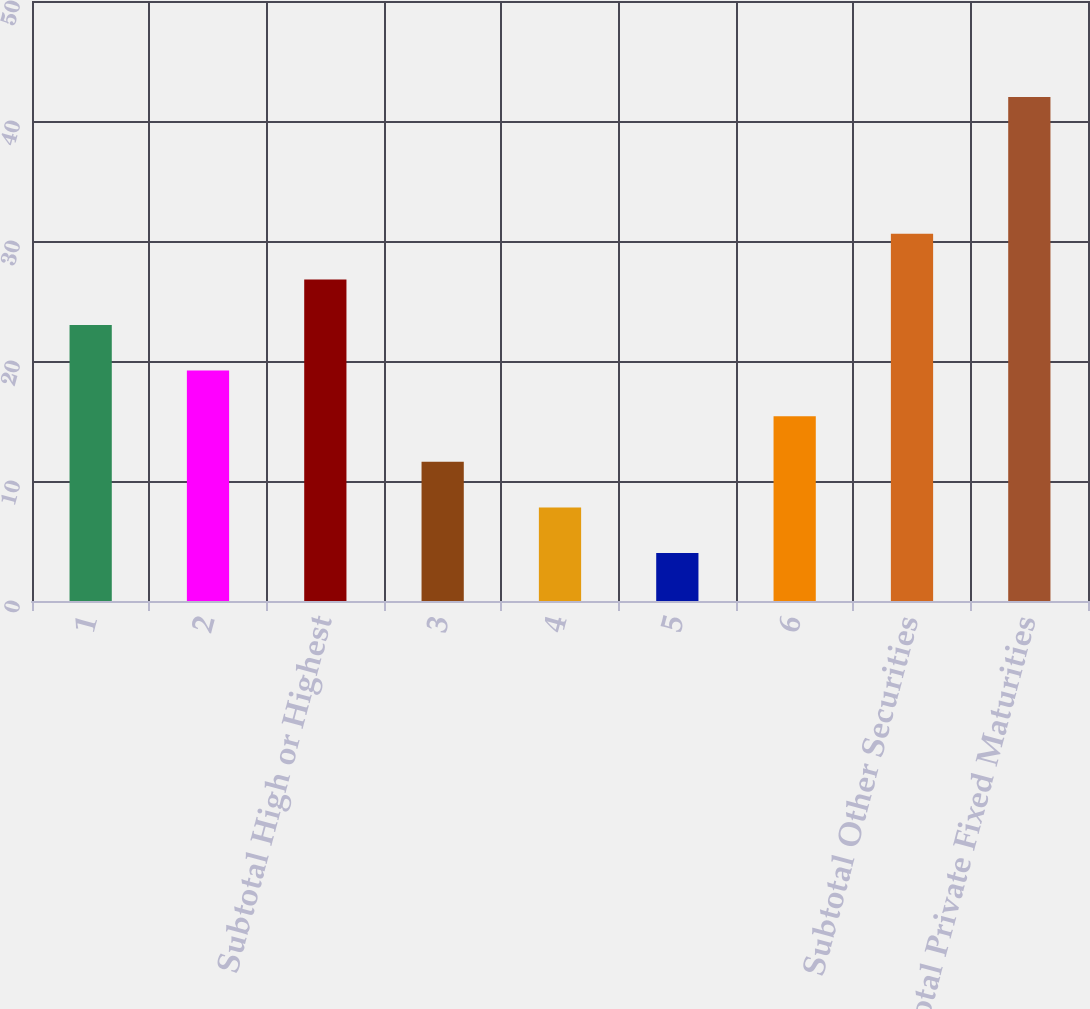Convert chart to OTSL. <chart><loc_0><loc_0><loc_500><loc_500><bar_chart><fcel>1<fcel>2<fcel>Subtotal High or Highest<fcel>3<fcel>4<fcel>5<fcel>6<fcel>Subtotal Other Securities<fcel>Total Private Fixed Maturities<nl><fcel>23<fcel>19.2<fcel>26.8<fcel>11.6<fcel>7.8<fcel>4<fcel>15.4<fcel>30.6<fcel>42<nl></chart> 